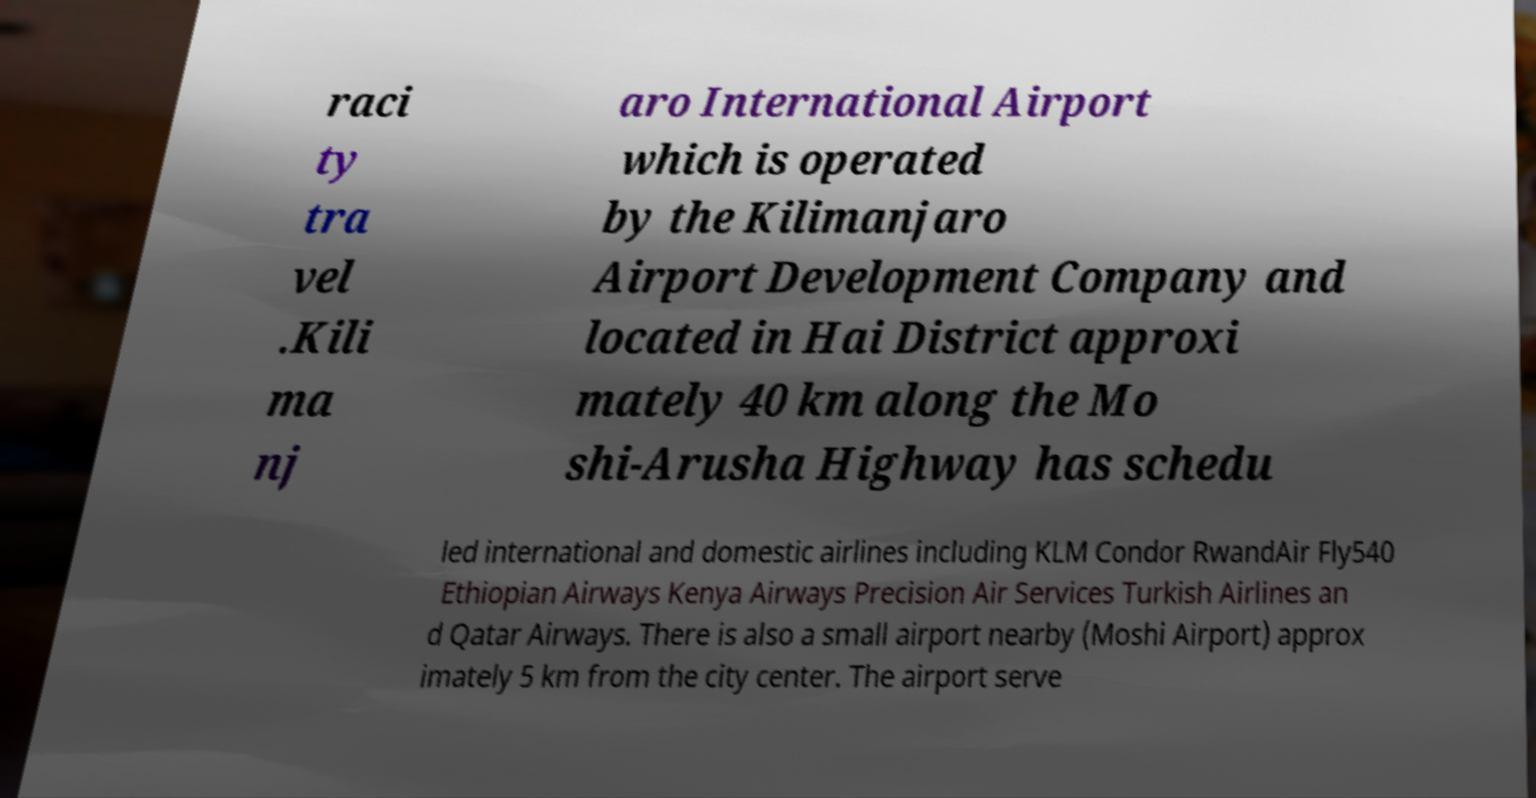Could you assist in decoding the text presented in this image and type it out clearly? raci ty tra vel .Kili ma nj aro International Airport which is operated by the Kilimanjaro Airport Development Company and located in Hai District approxi mately 40 km along the Mo shi-Arusha Highway has schedu led international and domestic airlines including KLM Condor RwandAir Fly540 Ethiopian Airways Kenya Airways Precision Air Services Turkish Airlines an d Qatar Airways. There is also a small airport nearby (Moshi Airport) approx imately 5 km from the city center. The airport serve 